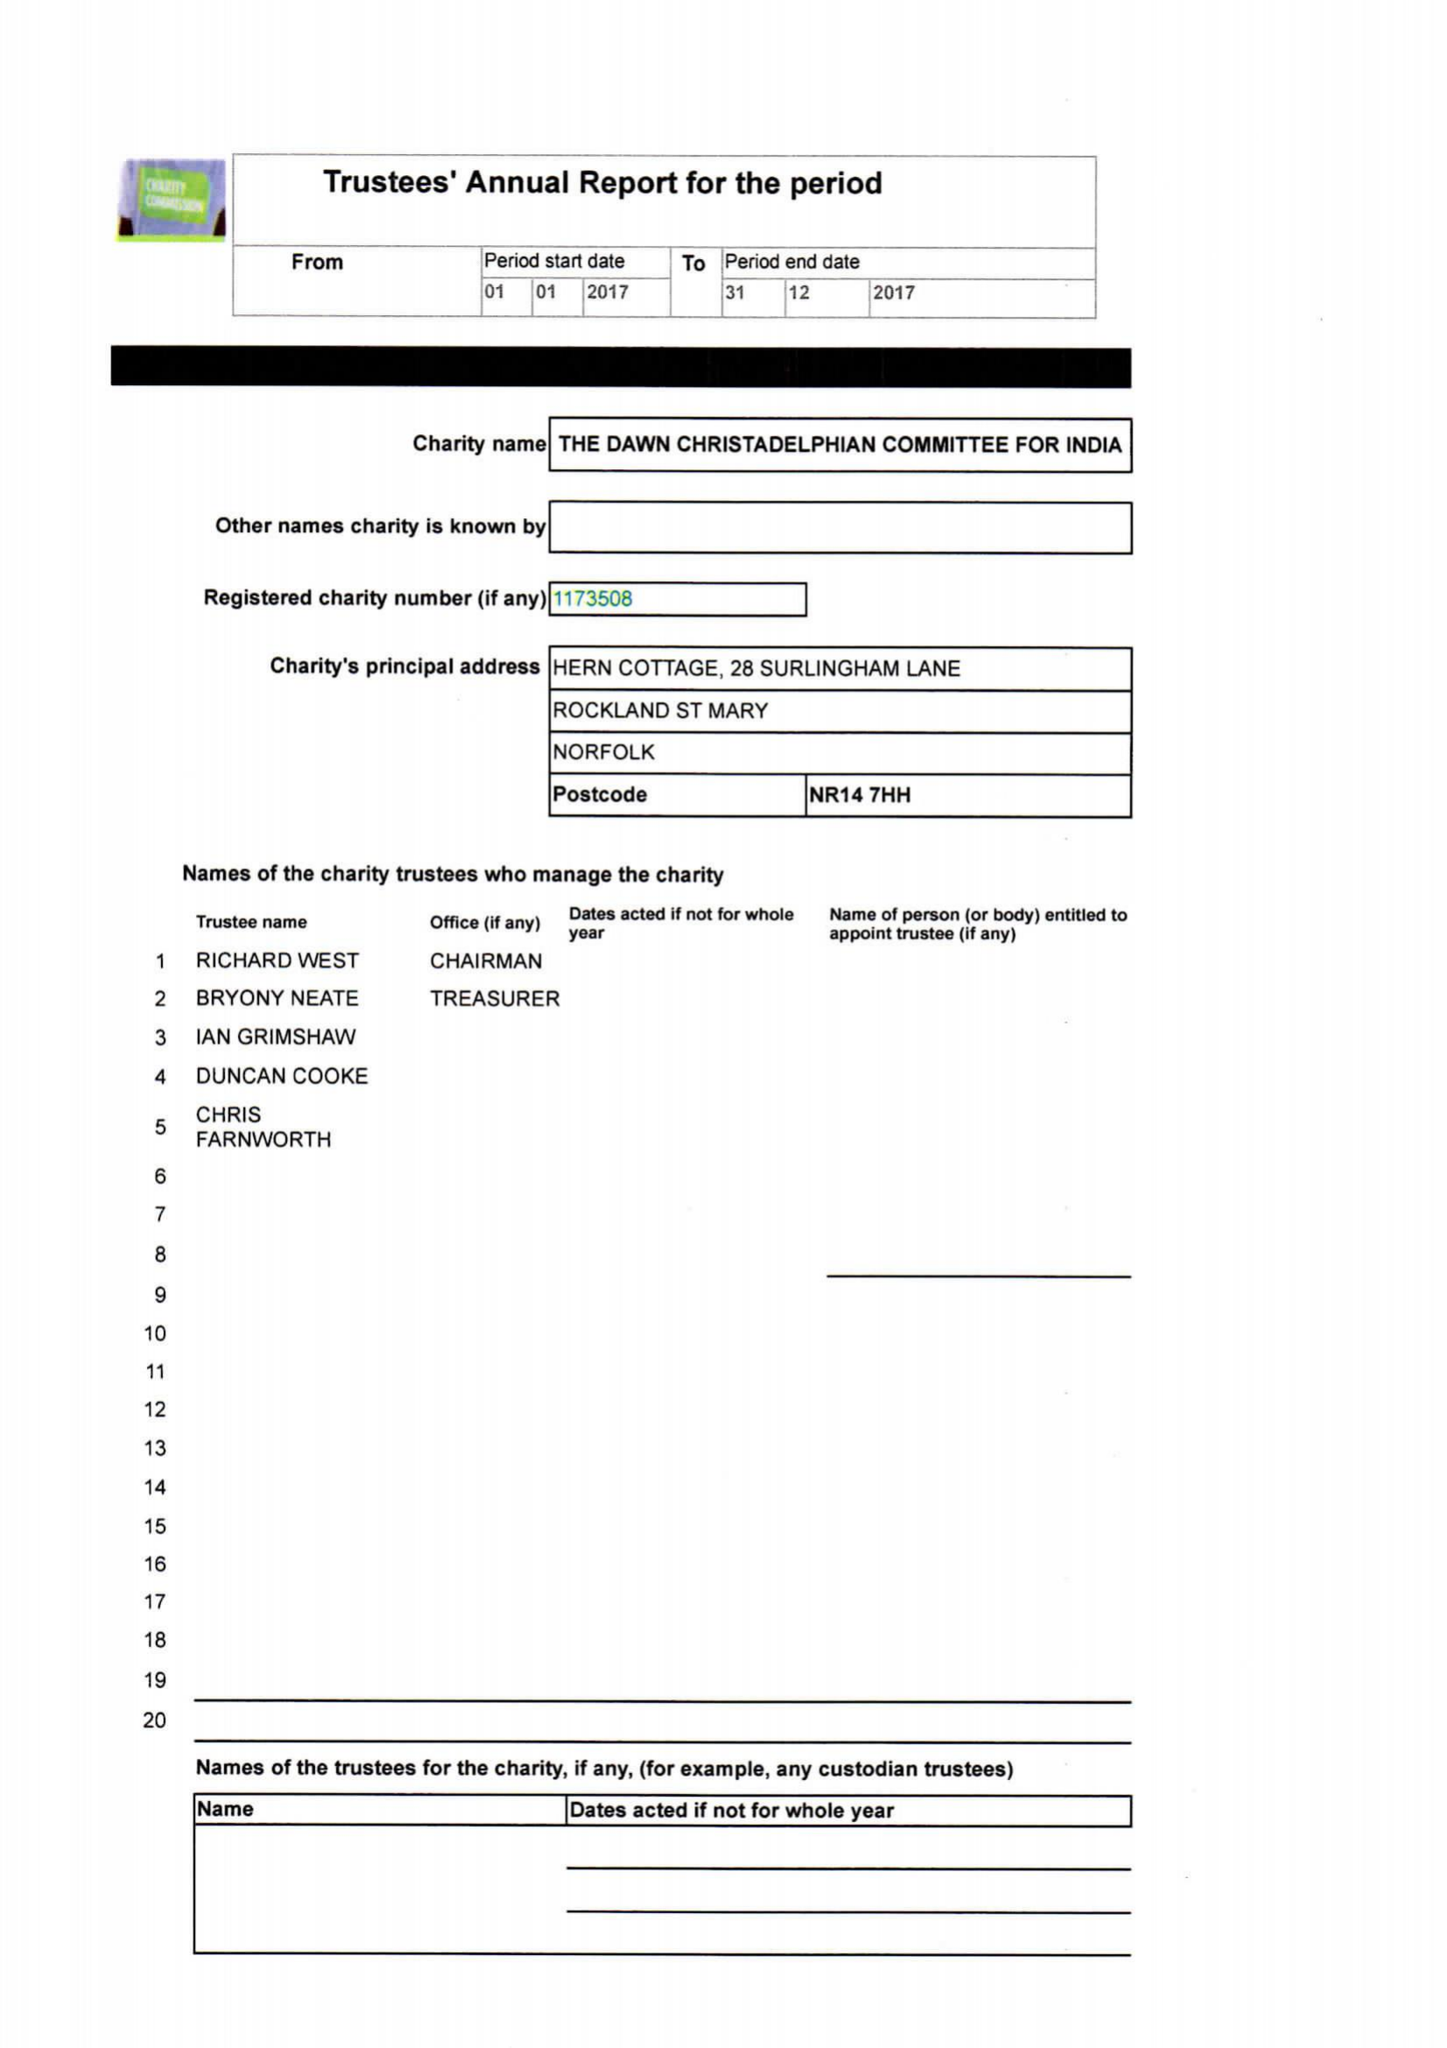What is the value for the address__post_town?
Answer the question using a single word or phrase. NORWICH 